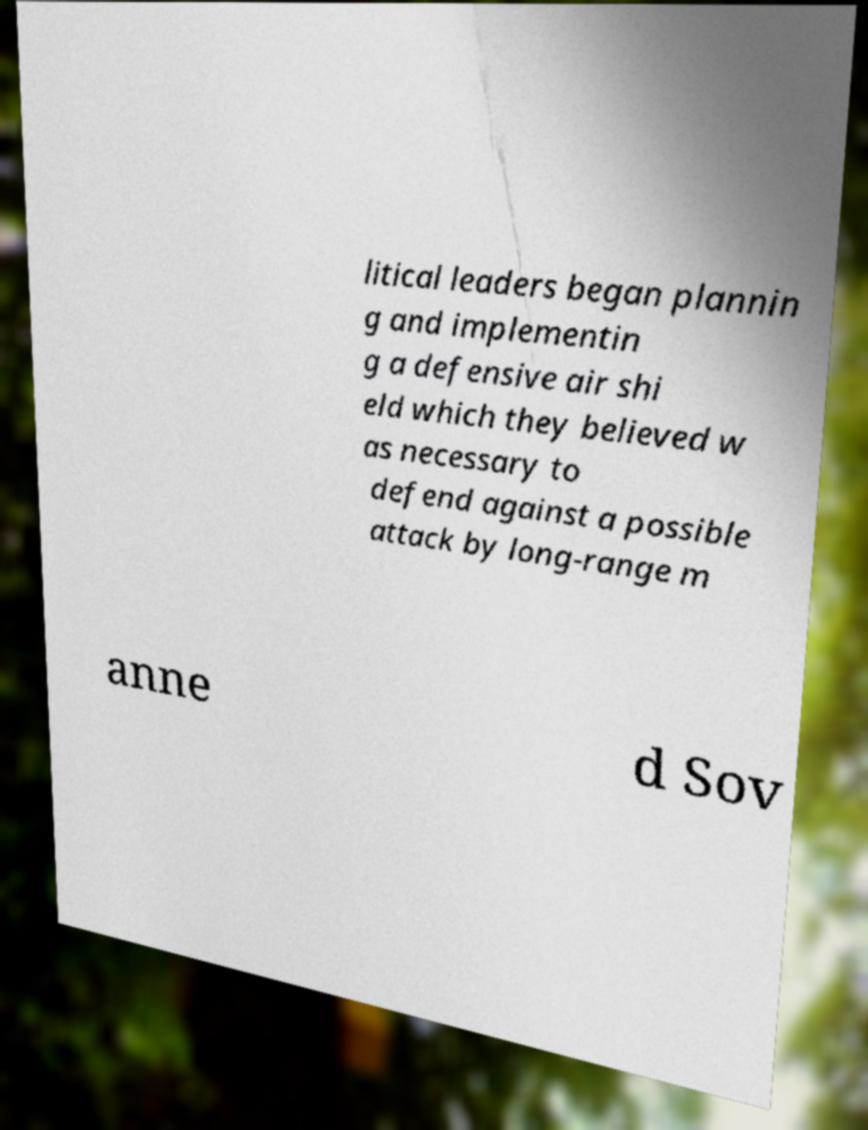I need the written content from this picture converted into text. Can you do that? litical leaders began plannin g and implementin g a defensive air shi eld which they believed w as necessary to defend against a possible attack by long-range m anne d Sov 